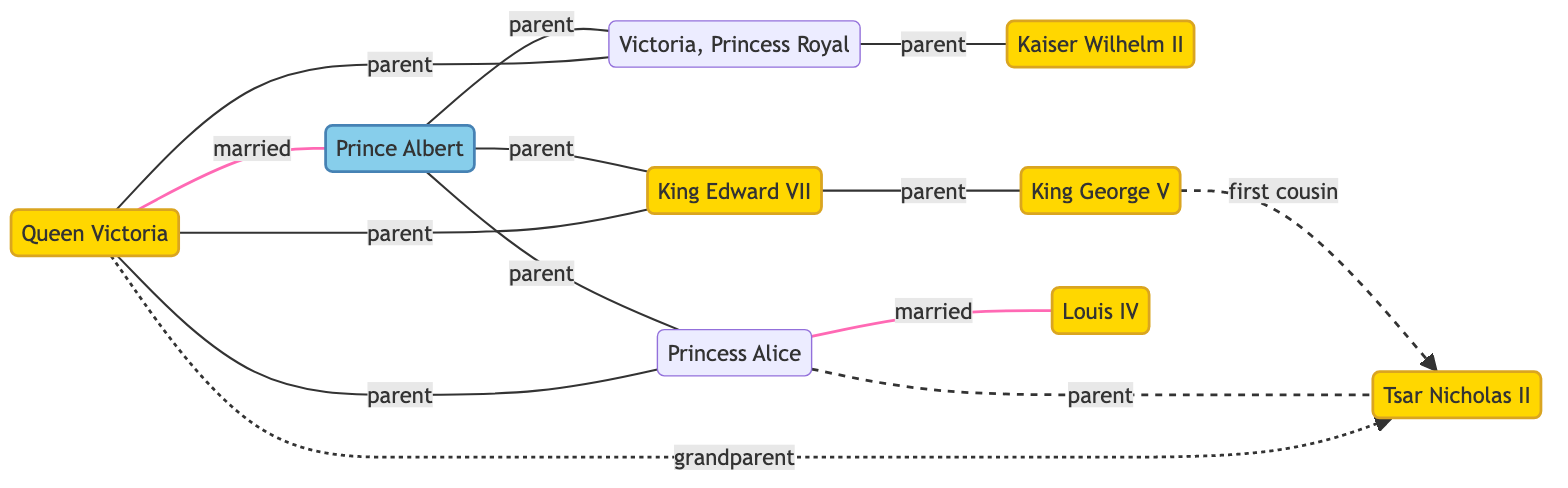What is the relationship between Queen Victoria and Prince Albert? In the diagram, a connection labeled "married" exists between Queen Victoria and Prince Albert, indicating their marital relationship.
Answer: married How many children did Queen Victoria have? By examining the diagram, we see three nodes directly connected to Queen Victoria labeled as King Edward VII, Princess Alice, and Princess Victoria, indicating she had three children.
Answer: 3 Who is the parent of King George V? King Edward VII is connected to King George V with a relationship labeled "parent," indicating that King Edward VII is his father.
Answer: King Edward VII Which two individuals are first cousins? The diagram shows that King George V and Tsar Nicholas II have a dashed connection tagged "first cousin," which indicates their relationship.
Answer: King George V and Tsar Nicholas II Who is the child of Princess Victoria? The diagram shows that Princess Victoria is connected to Kaiser Wilhelm II with a relationship labeled "parent," indicating that Kaiser Wilhelm II is her child.
Answer: Kaiser Wilhelm II How many total nodes are present in the diagram? Counting the nodes listed in the data, there are eight persons represented in the diagram, which means there are a total of eight nodes.
Answer: 8 What is the relationship between Princess Alice and Louis IV? The connection between Princess Alice and Louis IV in the diagram is labeled "married," indicating their marital relationship.
Answer: married Who is the grandchild of Queen Victoria? The connection labeled "grandparent" between Queen Victoria and Tsar Nicholas II indicates that Tsar Nicholas II is her grandchild.
Answer: Tsar Nicholas II What type of relationship does Princess Alice have with Tsar Nicholas II? The diagram shows a direct connection from Princess Alice to Tsar Nicholas II labeled "parent," indicating that Princess Alice is his mother.
Answer: parent 